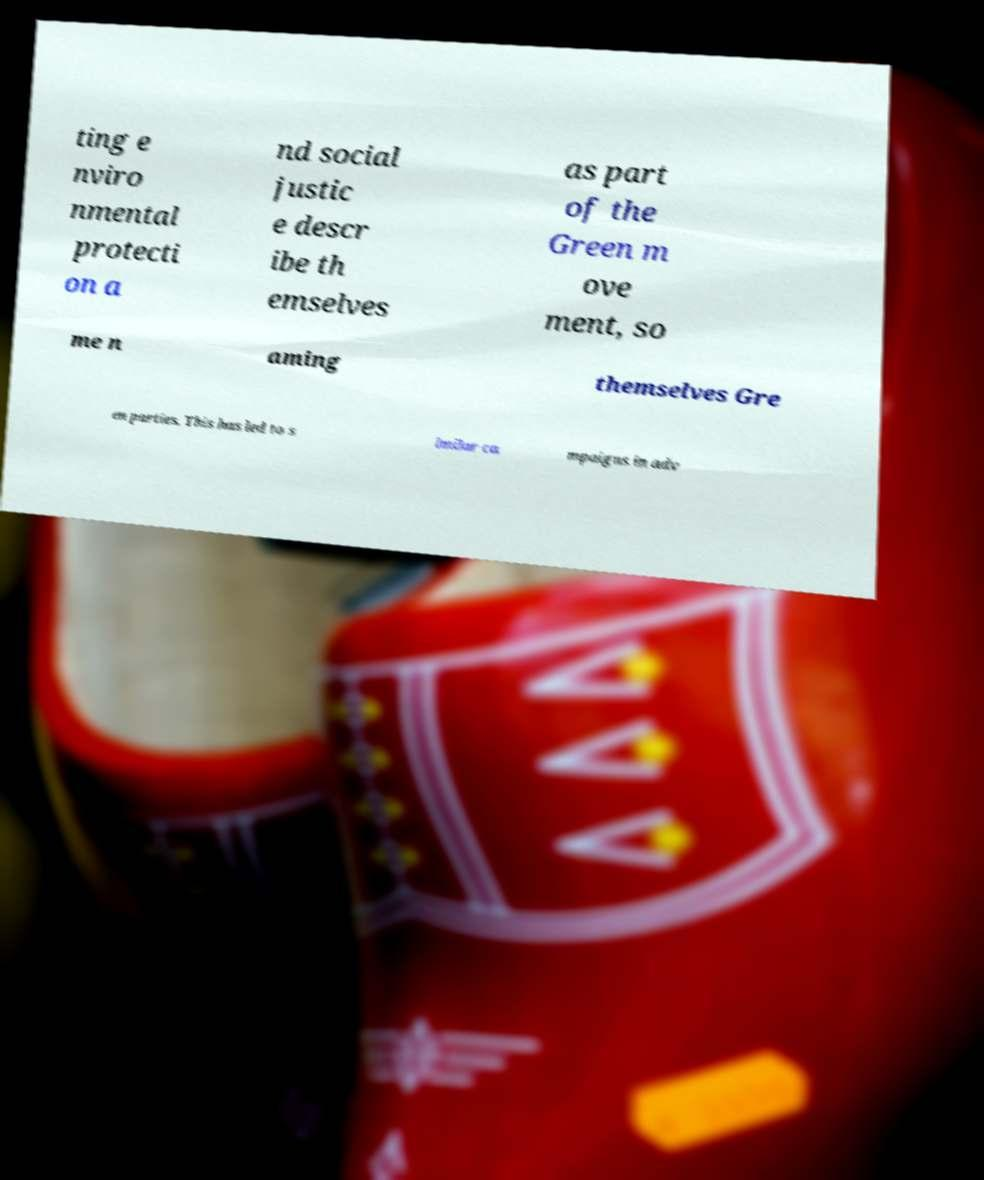Could you assist in decoding the text presented in this image and type it out clearly? ting e nviro nmental protecti on a nd social justic e descr ibe th emselves as part of the Green m ove ment, so me n aming themselves Gre en parties. This has led to s imilar ca mpaigns in adv 